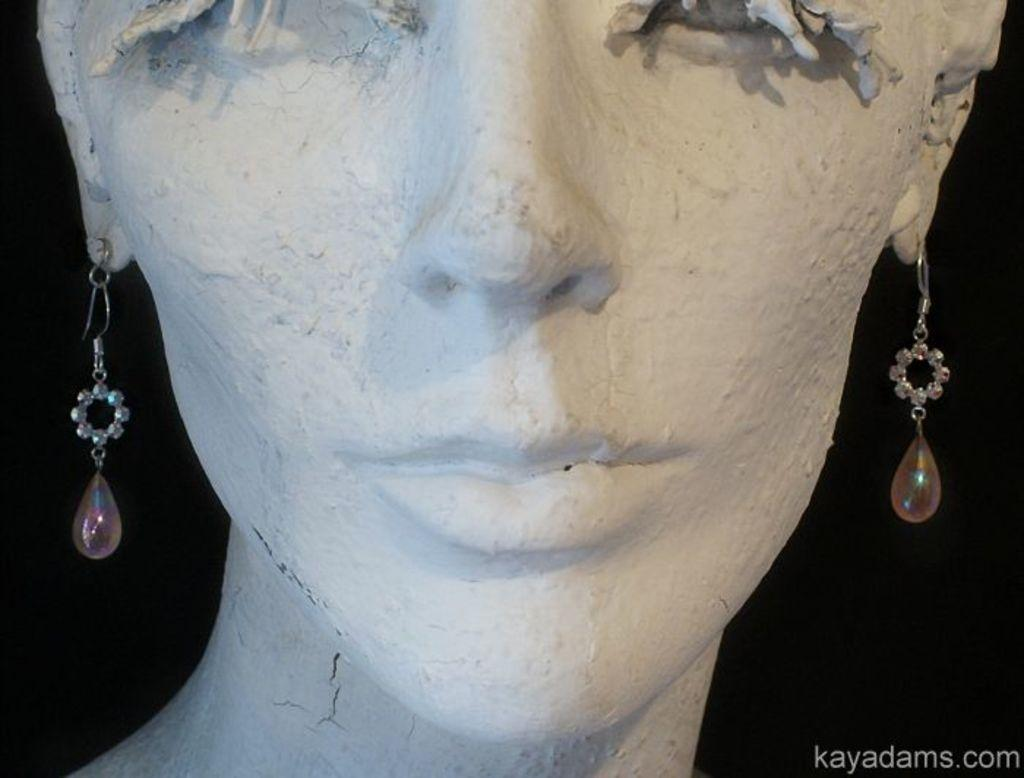What is the main subject in the image? There is a statue in the image. Can you describe any other elements in the image? There is text visible in the background of the image. How many robins are perched on the statue in the image? There are no robins present in the image; it only features a statue and text in the background. What type of mountain can be seen in the background of the image? There is no mountain visible in the image; it only features a statue and text in the background. 